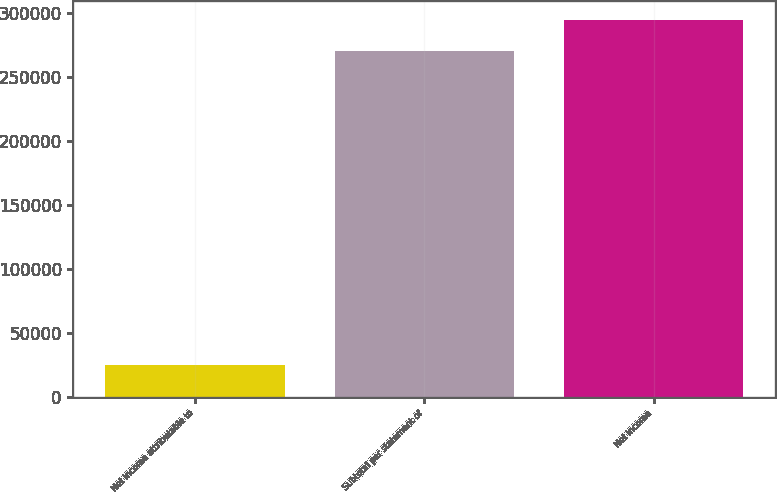Convert chart to OTSL. <chart><loc_0><loc_0><loc_500><loc_500><bar_chart><fcel>Net income attributable to<fcel>Subtotal per statement of<fcel>Net income<nl><fcel>24666<fcel>269952<fcel>294481<nl></chart> 